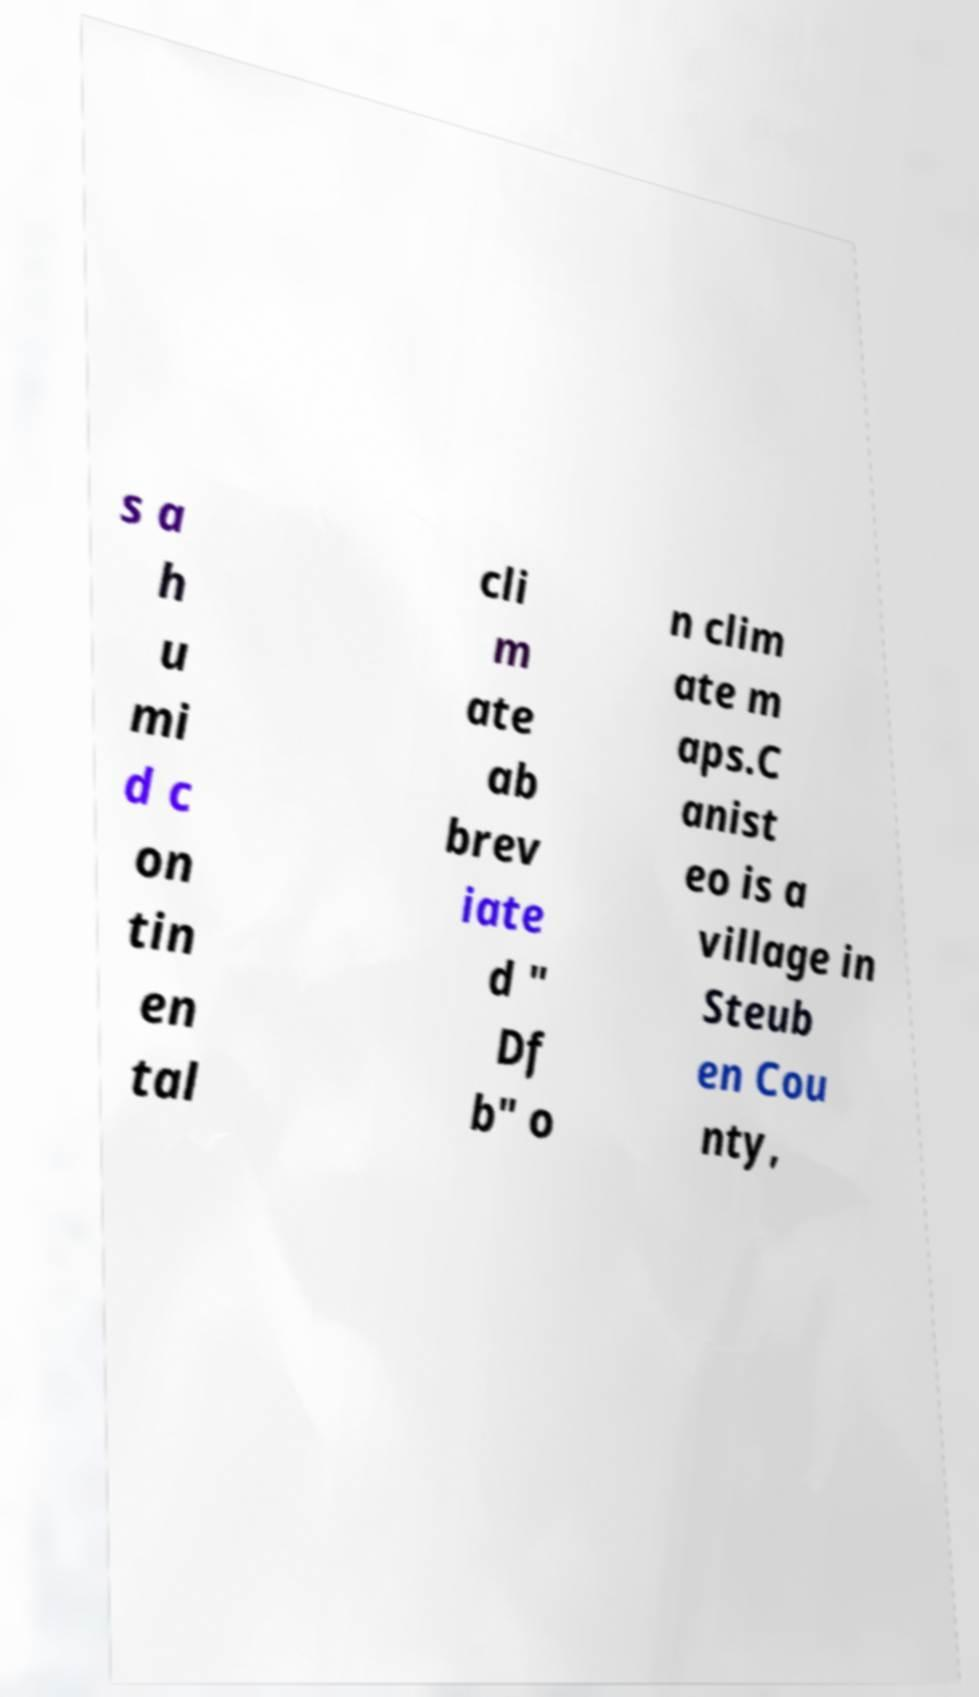Please read and relay the text visible in this image. What does it say? s a h u mi d c on tin en tal cli m ate ab brev iate d " Df b" o n clim ate m aps.C anist eo is a village in Steub en Cou nty, 